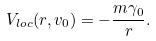<formula> <loc_0><loc_0><loc_500><loc_500>V _ { l o c } ( r , v _ { 0 } ) = - \frac { m \gamma _ { 0 } } { r } .</formula> 